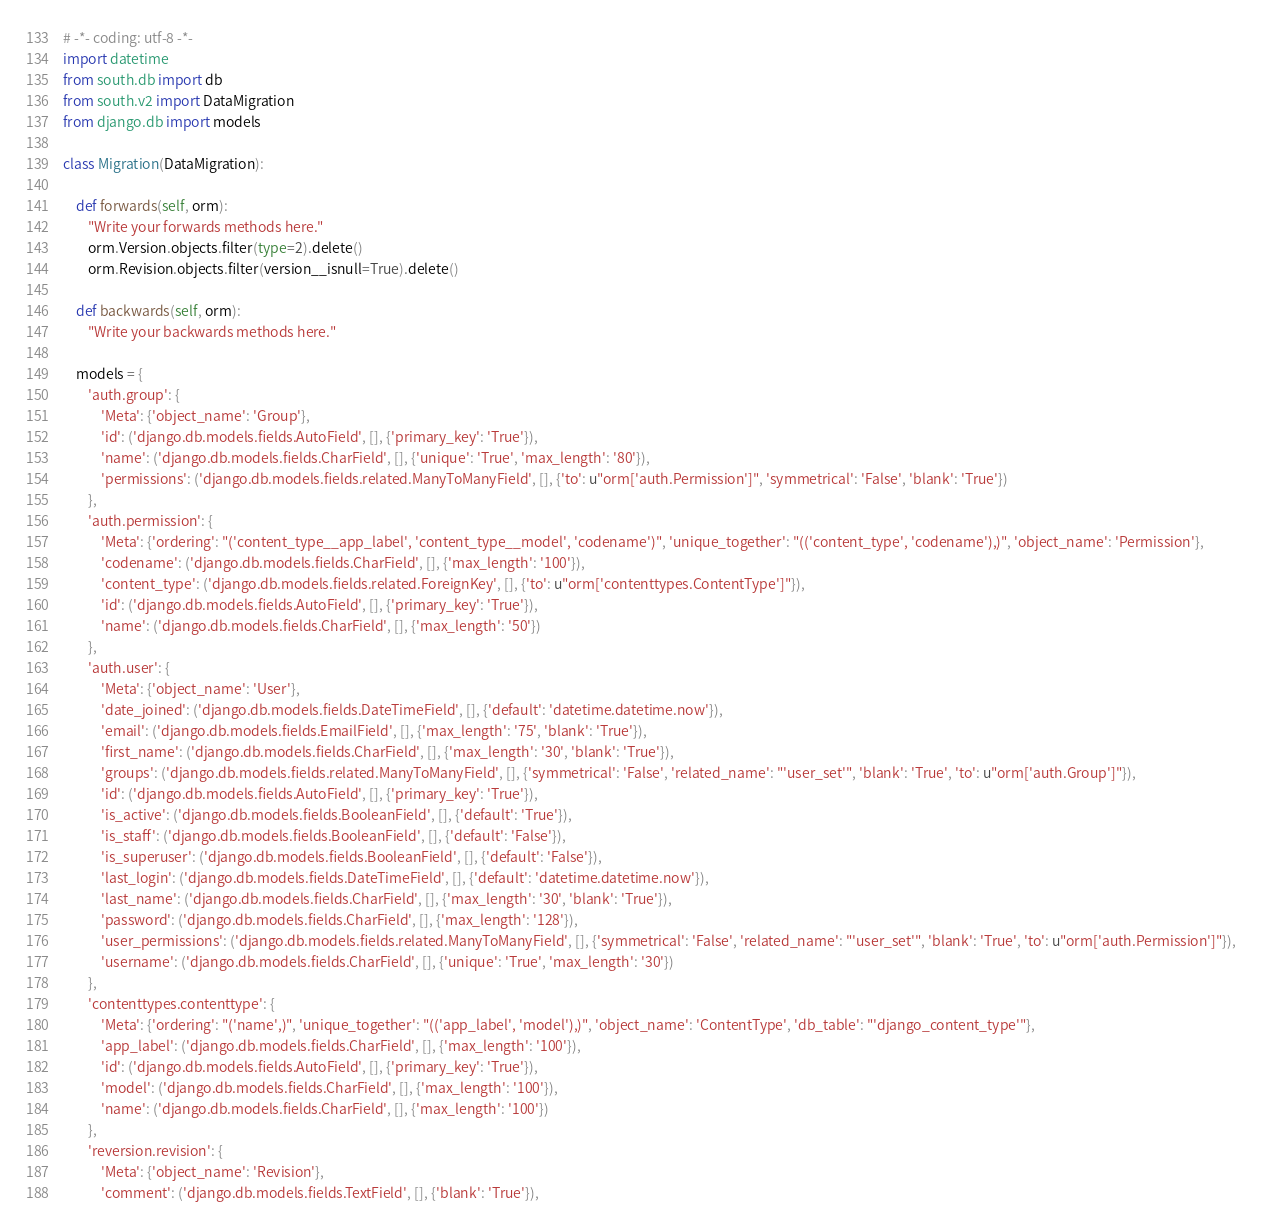Convert code to text. <code><loc_0><loc_0><loc_500><loc_500><_Python_># -*- coding: utf-8 -*-
import datetime
from south.db import db
from south.v2 import DataMigration
from django.db import models

class Migration(DataMigration):

    def forwards(self, orm):
        "Write your forwards methods here."
        orm.Version.objects.filter(type=2).delete()
        orm.Revision.objects.filter(version__isnull=True).delete()

    def backwards(self, orm):
        "Write your backwards methods here."

    models = {
        'auth.group': {
            'Meta': {'object_name': 'Group'},
            'id': ('django.db.models.fields.AutoField', [], {'primary_key': 'True'}),
            'name': ('django.db.models.fields.CharField', [], {'unique': 'True', 'max_length': '80'}),
            'permissions': ('django.db.models.fields.related.ManyToManyField', [], {'to': u"orm['auth.Permission']", 'symmetrical': 'False', 'blank': 'True'})
        },
        'auth.permission': {
            'Meta': {'ordering': "('content_type__app_label', 'content_type__model', 'codename')", 'unique_together': "(('content_type', 'codename'),)", 'object_name': 'Permission'},
            'codename': ('django.db.models.fields.CharField', [], {'max_length': '100'}),
            'content_type': ('django.db.models.fields.related.ForeignKey', [], {'to': u"orm['contenttypes.ContentType']"}),
            'id': ('django.db.models.fields.AutoField', [], {'primary_key': 'True'}),
            'name': ('django.db.models.fields.CharField', [], {'max_length': '50'})
        },
        'auth.user': {
            'Meta': {'object_name': 'User'},
            'date_joined': ('django.db.models.fields.DateTimeField', [], {'default': 'datetime.datetime.now'}),
            'email': ('django.db.models.fields.EmailField', [], {'max_length': '75', 'blank': 'True'}),
            'first_name': ('django.db.models.fields.CharField', [], {'max_length': '30', 'blank': 'True'}),
            'groups': ('django.db.models.fields.related.ManyToManyField', [], {'symmetrical': 'False', 'related_name': "'user_set'", 'blank': 'True', 'to': u"orm['auth.Group']"}),
            'id': ('django.db.models.fields.AutoField', [], {'primary_key': 'True'}),
            'is_active': ('django.db.models.fields.BooleanField', [], {'default': 'True'}),
            'is_staff': ('django.db.models.fields.BooleanField', [], {'default': 'False'}),
            'is_superuser': ('django.db.models.fields.BooleanField', [], {'default': 'False'}),
            'last_login': ('django.db.models.fields.DateTimeField', [], {'default': 'datetime.datetime.now'}),
            'last_name': ('django.db.models.fields.CharField', [], {'max_length': '30', 'blank': 'True'}),
            'password': ('django.db.models.fields.CharField', [], {'max_length': '128'}),
            'user_permissions': ('django.db.models.fields.related.ManyToManyField', [], {'symmetrical': 'False', 'related_name': "'user_set'", 'blank': 'True', 'to': u"orm['auth.Permission']"}),
            'username': ('django.db.models.fields.CharField', [], {'unique': 'True', 'max_length': '30'})
        },
        'contenttypes.contenttype': {
            'Meta': {'ordering': "('name',)", 'unique_together': "(('app_label', 'model'),)", 'object_name': 'ContentType', 'db_table': "'django_content_type'"},
            'app_label': ('django.db.models.fields.CharField', [], {'max_length': '100'}),
            'id': ('django.db.models.fields.AutoField', [], {'primary_key': 'True'}),
            'model': ('django.db.models.fields.CharField', [], {'max_length': '100'}),
            'name': ('django.db.models.fields.CharField', [], {'max_length': '100'})
        },
        'reversion.revision': {
            'Meta': {'object_name': 'Revision'},
            'comment': ('django.db.models.fields.TextField', [], {'blank': 'True'}),</code> 